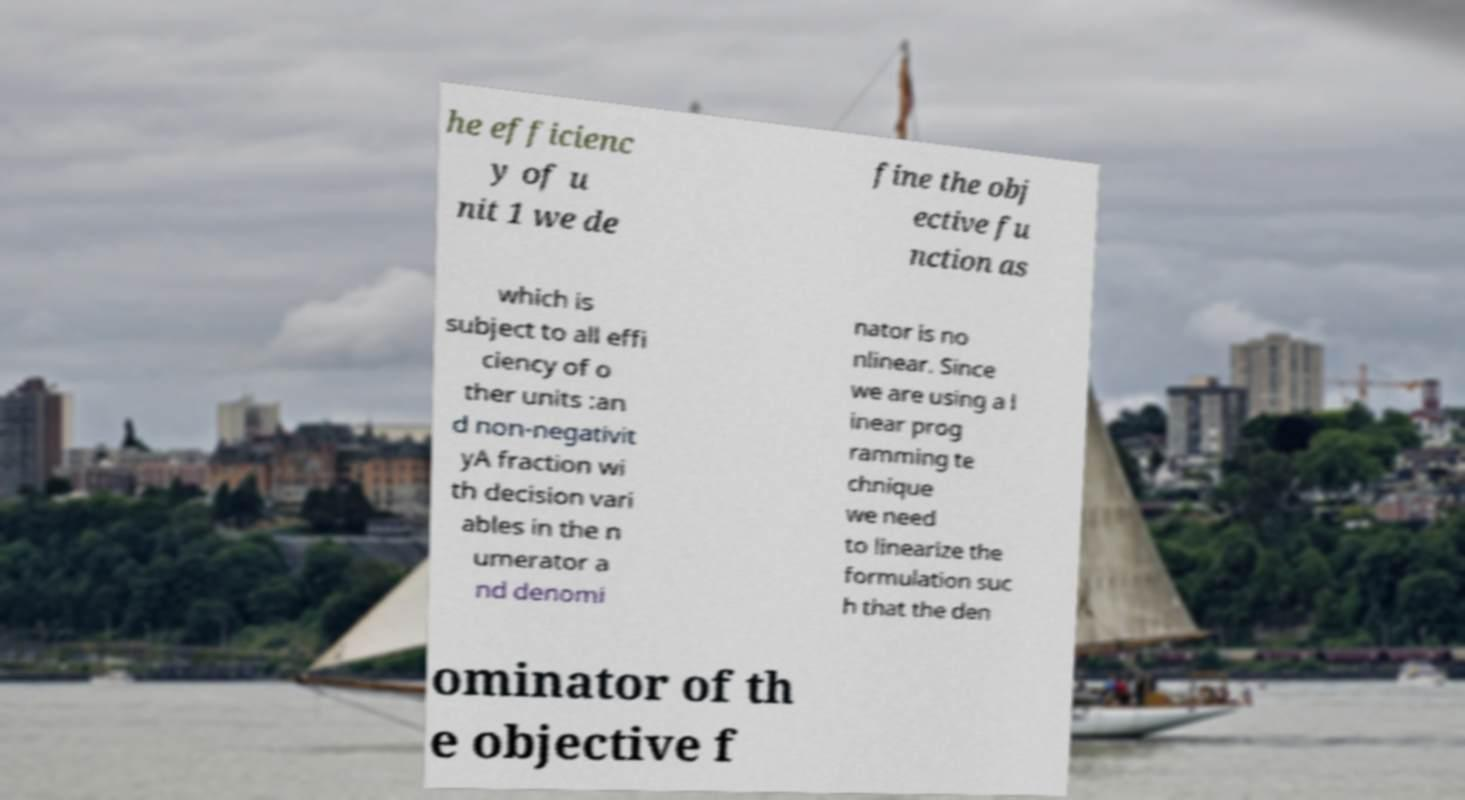There's text embedded in this image that I need extracted. Can you transcribe it verbatim? he efficienc y of u nit 1 we de fine the obj ective fu nction as which is subject to all effi ciency of o ther units :an d non-negativit yA fraction wi th decision vari ables in the n umerator a nd denomi nator is no nlinear. Since we are using a l inear prog ramming te chnique we need to linearize the formulation suc h that the den ominator of th e objective f 